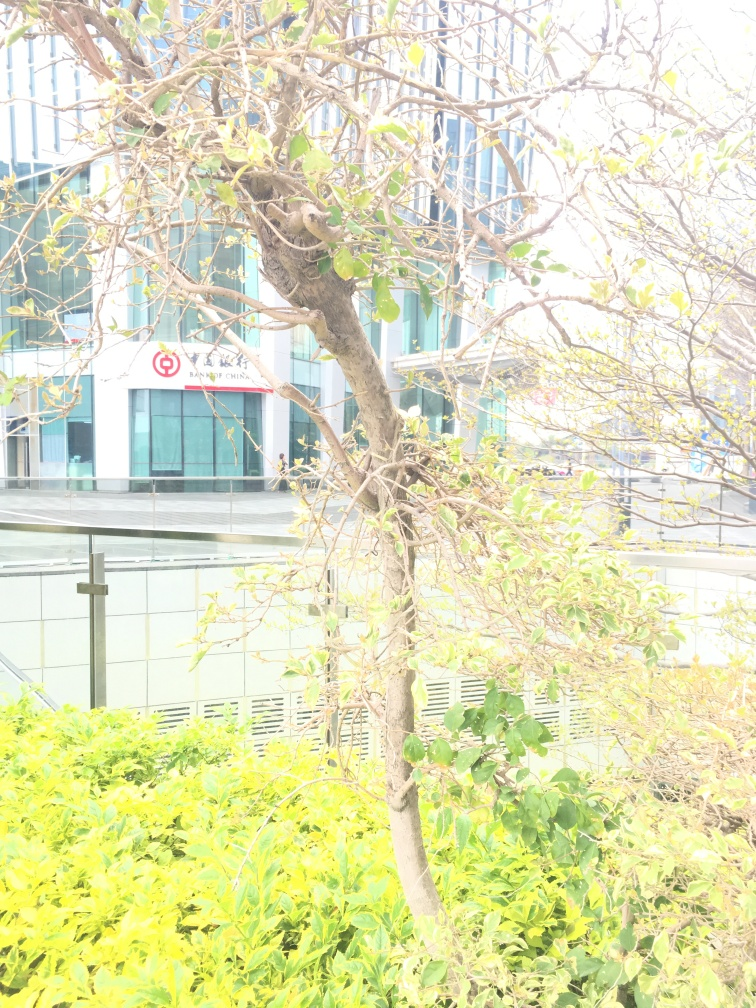Aside from the plant's texture details, is there anything else that might have been affected by the overexposure? Yes, aside from the plant's texture details, the overexposure likely affected the color fidelity of the image. The vibrant greens of the plants might be rendered less accurately, and other subtle color variations in the scene would be harder to distinguish. Shadows and highlights that give a sense of depth and dimensionality to the photograph would also be minimized. 